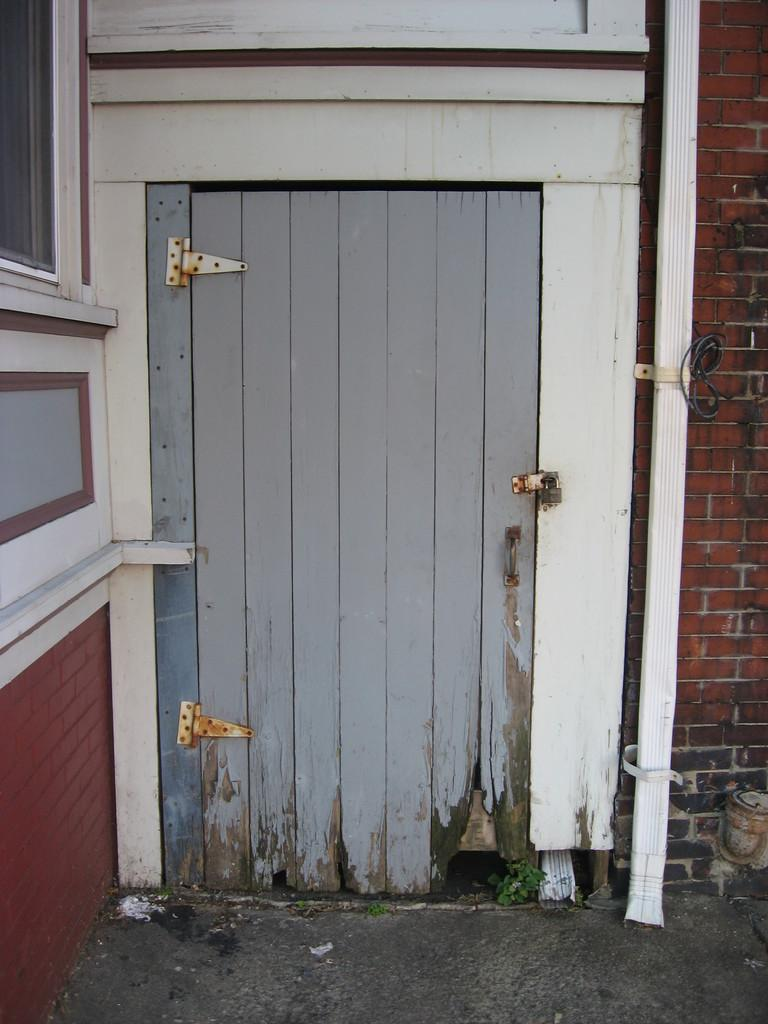What type of door is visible in the image? There is a wooden door in the image. What else can be seen in the image besides the door? There is a wall in the image. What type of question is being asked in the image? There is no question present in the image; it only features a wooden door and a wall. 